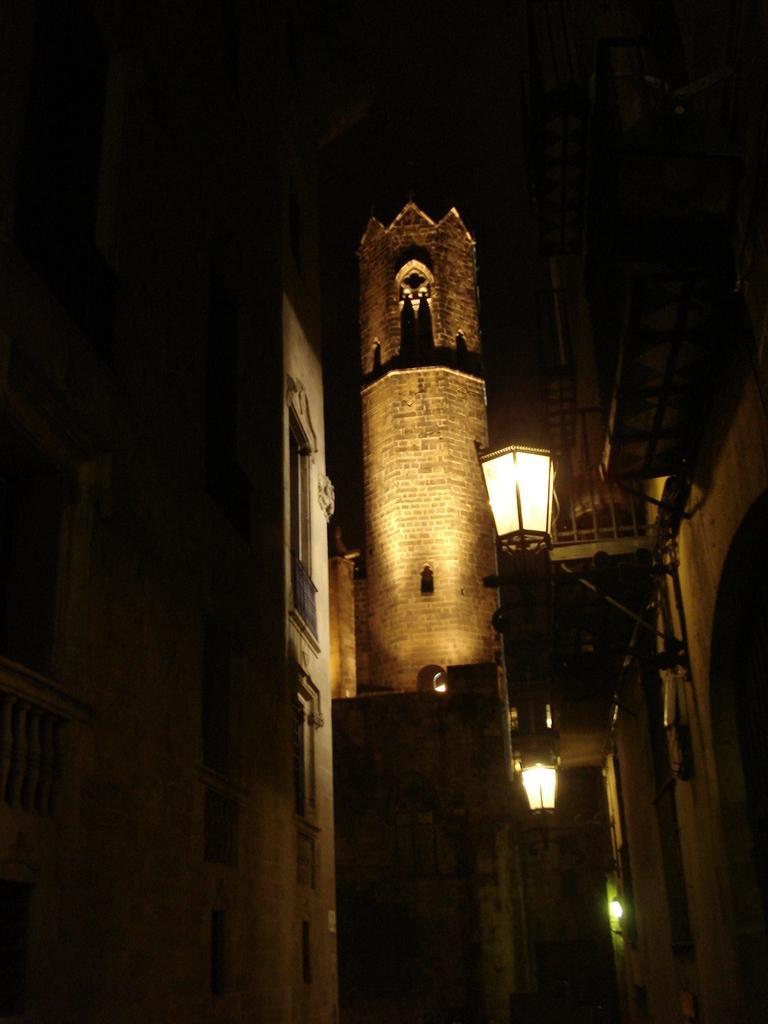Can you describe this image briefly? In this picture we can see a fort, few buildings, lights and metal rods. 